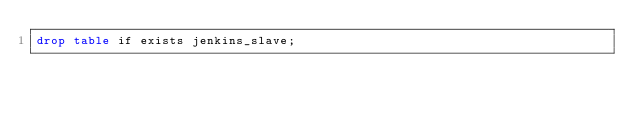Convert code to text. <code><loc_0><loc_0><loc_500><loc_500><_SQL_>drop table if exists jenkins_slave;</code> 